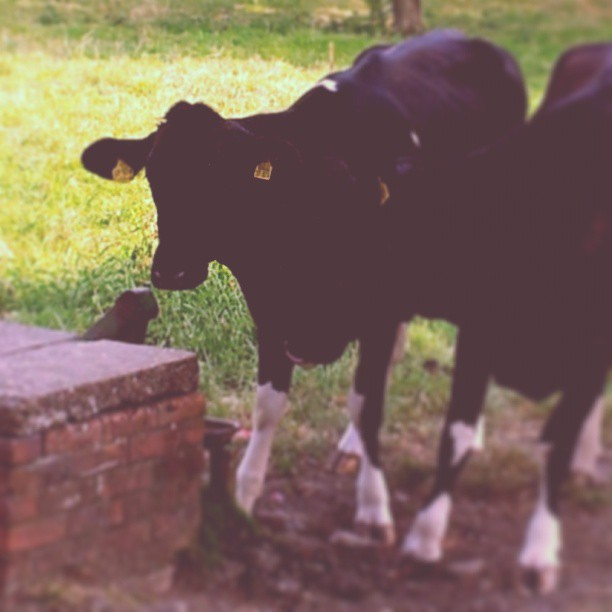<image>What is the cow on the left looking at? It is unknown what the cow on the left is looking at. It could be bricks, water, another animal, the camera, or the ground. What is the cow on the left looking at? I don't know what the cow on the left is looking at. It could be looking at bricks, a brick wall, water, or something else. 